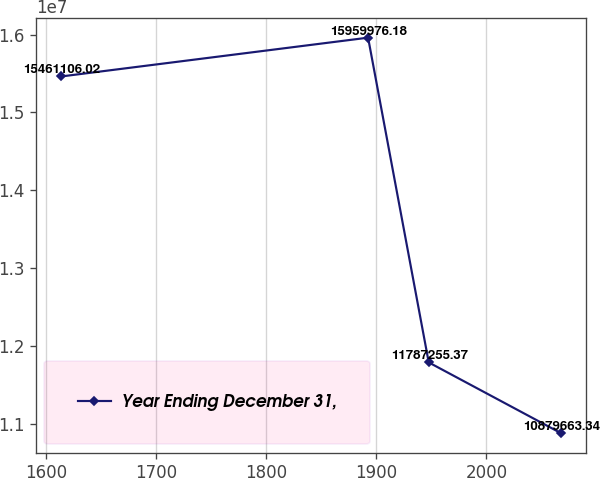Convert chart. <chart><loc_0><loc_0><loc_500><loc_500><line_chart><ecel><fcel>Year Ending December 31,<nl><fcel>1613.67<fcel>1.54611e+07<nl><fcel>1892.61<fcel>1.596e+07<nl><fcel>1947.69<fcel>1.17873e+07<nl><fcel>2067.6<fcel>1.08797e+07<nl></chart> 